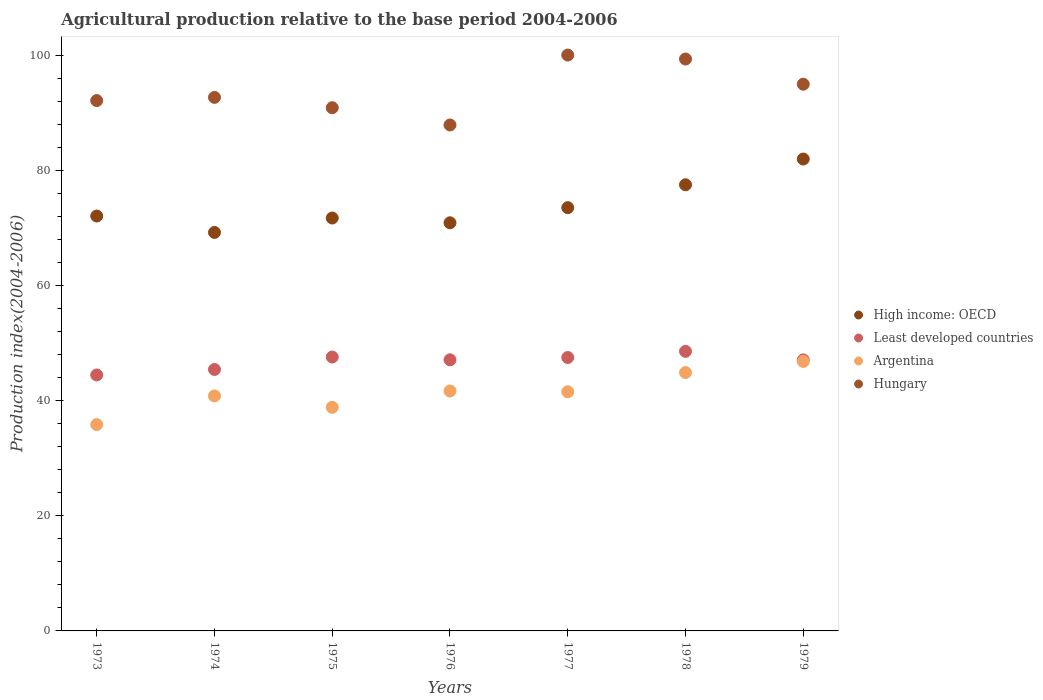Is the number of dotlines equal to the number of legend labels?
Make the answer very short. Yes. What is the agricultural production index in Hungary in 1974?
Make the answer very short. 92.79. Across all years, what is the maximum agricultural production index in Least developed countries?
Your response must be concise. 48.62. Across all years, what is the minimum agricultural production index in High income: OECD?
Your answer should be compact. 69.3. In which year was the agricultural production index in Hungary maximum?
Offer a terse response. 1977. In which year was the agricultural production index in Argentina minimum?
Your response must be concise. 1973. What is the total agricultural production index in Hungary in the graph?
Your answer should be very brief. 658.69. What is the difference between the agricultural production index in Hungary in 1974 and that in 1979?
Provide a succinct answer. -2.29. What is the difference between the agricultural production index in High income: OECD in 1979 and the agricultural production index in Hungary in 1976?
Make the answer very short. -5.92. What is the average agricultural production index in Least developed countries per year?
Offer a very short reply. 46.87. In the year 1979, what is the difference between the agricultural production index in High income: OECD and agricultural production index in Argentina?
Your answer should be very brief. 35.2. What is the ratio of the agricultural production index in Argentina in 1975 to that in 1979?
Offer a terse response. 0.83. Is the agricultural production index in Hungary in 1976 less than that in 1978?
Ensure brevity in your answer.  Yes. What is the difference between the highest and the second highest agricultural production index in Hungary?
Provide a succinct answer. 0.69. What is the difference between the highest and the lowest agricultural production index in Hungary?
Your answer should be very brief. 12.16. Is the sum of the agricultural production index in Least developed countries in 1976 and 1978 greater than the maximum agricultural production index in Hungary across all years?
Offer a very short reply. No. Is it the case that in every year, the sum of the agricultural production index in High income: OECD and agricultural production index in Argentina  is greater than the sum of agricultural production index in Hungary and agricultural production index in Least developed countries?
Your answer should be compact. Yes. How many years are there in the graph?
Offer a very short reply. 7. Are the values on the major ticks of Y-axis written in scientific E-notation?
Keep it short and to the point. No. Where does the legend appear in the graph?
Give a very brief answer. Center right. How are the legend labels stacked?
Your answer should be very brief. Vertical. What is the title of the graph?
Make the answer very short. Agricultural production relative to the base period 2004-2006. Does "East Asia (developing only)" appear as one of the legend labels in the graph?
Offer a terse response. No. What is the label or title of the X-axis?
Give a very brief answer. Years. What is the label or title of the Y-axis?
Provide a succinct answer. Production index(2004-2006). What is the Production index(2004-2006) in High income: OECD in 1973?
Your answer should be compact. 72.15. What is the Production index(2004-2006) in Least developed countries in 1973?
Provide a short and direct response. 44.51. What is the Production index(2004-2006) in Argentina in 1973?
Your answer should be compact. 35.88. What is the Production index(2004-2006) of Hungary in 1973?
Offer a terse response. 92.23. What is the Production index(2004-2006) of High income: OECD in 1974?
Provide a short and direct response. 69.3. What is the Production index(2004-2006) in Least developed countries in 1974?
Make the answer very short. 45.47. What is the Production index(2004-2006) in Argentina in 1974?
Provide a short and direct response. 40.87. What is the Production index(2004-2006) of Hungary in 1974?
Make the answer very short. 92.79. What is the Production index(2004-2006) of High income: OECD in 1975?
Give a very brief answer. 71.81. What is the Production index(2004-2006) in Least developed countries in 1975?
Provide a short and direct response. 47.63. What is the Production index(2004-2006) of Argentina in 1975?
Ensure brevity in your answer.  38.89. What is the Production index(2004-2006) in Hungary in 1975?
Your answer should be very brief. 90.99. What is the Production index(2004-2006) of High income: OECD in 1976?
Ensure brevity in your answer.  70.98. What is the Production index(2004-2006) in Least developed countries in 1976?
Your answer should be very brief. 47.15. What is the Production index(2004-2006) of Argentina in 1976?
Ensure brevity in your answer.  41.73. What is the Production index(2004-2006) in Hungary in 1976?
Give a very brief answer. 87.99. What is the Production index(2004-2006) in High income: OECD in 1977?
Keep it short and to the point. 73.61. What is the Production index(2004-2006) in Least developed countries in 1977?
Give a very brief answer. 47.55. What is the Production index(2004-2006) of Argentina in 1977?
Provide a succinct answer. 41.59. What is the Production index(2004-2006) in Hungary in 1977?
Provide a succinct answer. 100.15. What is the Production index(2004-2006) of High income: OECD in 1978?
Provide a short and direct response. 77.59. What is the Production index(2004-2006) in Least developed countries in 1978?
Your response must be concise. 48.62. What is the Production index(2004-2006) of Argentina in 1978?
Give a very brief answer. 44.93. What is the Production index(2004-2006) in Hungary in 1978?
Give a very brief answer. 99.46. What is the Production index(2004-2006) of High income: OECD in 1979?
Your answer should be compact. 82.07. What is the Production index(2004-2006) in Least developed countries in 1979?
Offer a very short reply. 47.13. What is the Production index(2004-2006) of Argentina in 1979?
Ensure brevity in your answer.  46.87. What is the Production index(2004-2006) of Hungary in 1979?
Make the answer very short. 95.08. Across all years, what is the maximum Production index(2004-2006) of High income: OECD?
Offer a terse response. 82.07. Across all years, what is the maximum Production index(2004-2006) of Least developed countries?
Provide a short and direct response. 48.62. Across all years, what is the maximum Production index(2004-2006) in Argentina?
Offer a terse response. 46.87. Across all years, what is the maximum Production index(2004-2006) in Hungary?
Make the answer very short. 100.15. Across all years, what is the minimum Production index(2004-2006) in High income: OECD?
Provide a succinct answer. 69.3. Across all years, what is the minimum Production index(2004-2006) in Least developed countries?
Make the answer very short. 44.51. Across all years, what is the minimum Production index(2004-2006) in Argentina?
Make the answer very short. 35.88. Across all years, what is the minimum Production index(2004-2006) in Hungary?
Offer a very short reply. 87.99. What is the total Production index(2004-2006) of High income: OECD in the graph?
Offer a terse response. 517.51. What is the total Production index(2004-2006) in Least developed countries in the graph?
Provide a short and direct response. 328.07. What is the total Production index(2004-2006) of Argentina in the graph?
Provide a short and direct response. 290.76. What is the total Production index(2004-2006) of Hungary in the graph?
Make the answer very short. 658.69. What is the difference between the Production index(2004-2006) of High income: OECD in 1973 and that in 1974?
Keep it short and to the point. 2.85. What is the difference between the Production index(2004-2006) of Least developed countries in 1973 and that in 1974?
Keep it short and to the point. -0.96. What is the difference between the Production index(2004-2006) in Argentina in 1973 and that in 1974?
Ensure brevity in your answer.  -4.99. What is the difference between the Production index(2004-2006) in Hungary in 1973 and that in 1974?
Provide a short and direct response. -0.56. What is the difference between the Production index(2004-2006) in High income: OECD in 1973 and that in 1975?
Provide a short and direct response. 0.34. What is the difference between the Production index(2004-2006) in Least developed countries in 1973 and that in 1975?
Make the answer very short. -3.12. What is the difference between the Production index(2004-2006) of Argentina in 1973 and that in 1975?
Keep it short and to the point. -3.01. What is the difference between the Production index(2004-2006) in Hungary in 1973 and that in 1975?
Offer a very short reply. 1.24. What is the difference between the Production index(2004-2006) of High income: OECD in 1973 and that in 1976?
Ensure brevity in your answer.  1.18. What is the difference between the Production index(2004-2006) in Least developed countries in 1973 and that in 1976?
Offer a very short reply. -2.64. What is the difference between the Production index(2004-2006) of Argentina in 1973 and that in 1976?
Your response must be concise. -5.85. What is the difference between the Production index(2004-2006) of Hungary in 1973 and that in 1976?
Provide a succinct answer. 4.24. What is the difference between the Production index(2004-2006) in High income: OECD in 1973 and that in 1977?
Your answer should be compact. -1.46. What is the difference between the Production index(2004-2006) of Least developed countries in 1973 and that in 1977?
Give a very brief answer. -3.04. What is the difference between the Production index(2004-2006) in Argentina in 1973 and that in 1977?
Provide a succinct answer. -5.71. What is the difference between the Production index(2004-2006) of Hungary in 1973 and that in 1977?
Make the answer very short. -7.92. What is the difference between the Production index(2004-2006) of High income: OECD in 1973 and that in 1978?
Give a very brief answer. -5.44. What is the difference between the Production index(2004-2006) of Least developed countries in 1973 and that in 1978?
Provide a short and direct response. -4.11. What is the difference between the Production index(2004-2006) of Argentina in 1973 and that in 1978?
Your answer should be compact. -9.05. What is the difference between the Production index(2004-2006) of Hungary in 1973 and that in 1978?
Your answer should be compact. -7.23. What is the difference between the Production index(2004-2006) of High income: OECD in 1973 and that in 1979?
Provide a succinct answer. -9.91. What is the difference between the Production index(2004-2006) in Least developed countries in 1973 and that in 1979?
Your response must be concise. -2.62. What is the difference between the Production index(2004-2006) in Argentina in 1973 and that in 1979?
Provide a succinct answer. -10.99. What is the difference between the Production index(2004-2006) in Hungary in 1973 and that in 1979?
Give a very brief answer. -2.85. What is the difference between the Production index(2004-2006) of High income: OECD in 1974 and that in 1975?
Provide a short and direct response. -2.51. What is the difference between the Production index(2004-2006) of Least developed countries in 1974 and that in 1975?
Your answer should be very brief. -2.16. What is the difference between the Production index(2004-2006) of Argentina in 1974 and that in 1975?
Your response must be concise. 1.98. What is the difference between the Production index(2004-2006) in High income: OECD in 1974 and that in 1976?
Ensure brevity in your answer.  -1.68. What is the difference between the Production index(2004-2006) in Least developed countries in 1974 and that in 1976?
Ensure brevity in your answer.  -1.68. What is the difference between the Production index(2004-2006) in Argentina in 1974 and that in 1976?
Offer a terse response. -0.86. What is the difference between the Production index(2004-2006) of Hungary in 1974 and that in 1976?
Make the answer very short. 4.8. What is the difference between the Production index(2004-2006) of High income: OECD in 1974 and that in 1977?
Make the answer very short. -4.31. What is the difference between the Production index(2004-2006) of Least developed countries in 1974 and that in 1977?
Your response must be concise. -2.08. What is the difference between the Production index(2004-2006) of Argentina in 1974 and that in 1977?
Give a very brief answer. -0.72. What is the difference between the Production index(2004-2006) of Hungary in 1974 and that in 1977?
Your answer should be compact. -7.36. What is the difference between the Production index(2004-2006) in High income: OECD in 1974 and that in 1978?
Your answer should be compact. -8.29. What is the difference between the Production index(2004-2006) in Least developed countries in 1974 and that in 1978?
Keep it short and to the point. -3.15. What is the difference between the Production index(2004-2006) in Argentina in 1974 and that in 1978?
Make the answer very short. -4.06. What is the difference between the Production index(2004-2006) of Hungary in 1974 and that in 1978?
Offer a very short reply. -6.67. What is the difference between the Production index(2004-2006) in High income: OECD in 1974 and that in 1979?
Your response must be concise. -12.76. What is the difference between the Production index(2004-2006) in Least developed countries in 1974 and that in 1979?
Your answer should be compact. -1.66. What is the difference between the Production index(2004-2006) in Hungary in 1974 and that in 1979?
Provide a succinct answer. -2.29. What is the difference between the Production index(2004-2006) in High income: OECD in 1975 and that in 1976?
Provide a short and direct response. 0.83. What is the difference between the Production index(2004-2006) of Least developed countries in 1975 and that in 1976?
Provide a succinct answer. 0.48. What is the difference between the Production index(2004-2006) in Argentina in 1975 and that in 1976?
Offer a very short reply. -2.84. What is the difference between the Production index(2004-2006) in High income: OECD in 1975 and that in 1977?
Keep it short and to the point. -1.8. What is the difference between the Production index(2004-2006) of Least developed countries in 1975 and that in 1977?
Your answer should be very brief. 0.08. What is the difference between the Production index(2004-2006) of Hungary in 1975 and that in 1977?
Offer a terse response. -9.16. What is the difference between the Production index(2004-2006) in High income: OECD in 1975 and that in 1978?
Offer a very short reply. -5.78. What is the difference between the Production index(2004-2006) of Least developed countries in 1975 and that in 1978?
Make the answer very short. -0.99. What is the difference between the Production index(2004-2006) of Argentina in 1975 and that in 1978?
Provide a succinct answer. -6.04. What is the difference between the Production index(2004-2006) of Hungary in 1975 and that in 1978?
Offer a very short reply. -8.47. What is the difference between the Production index(2004-2006) of High income: OECD in 1975 and that in 1979?
Your response must be concise. -10.26. What is the difference between the Production index(2004-2006) of Least developed countries in 1975 and that in 1979?
Your answer should be compact. 0.5. What is the difference between the Production index(2004-2006) in Argentina in 1975 and that in 1979?
Your answer should be very brief. -7.98. What is the difference between the Production index(2004-2006) in Hungary in 1975 and that in 1979?
Your answer should be very brief. -4.09. What is the difference between the Production index(2004-2006) in High income: OECD in 1976 and that in 1977?
Provide a succinct answer. -2.63. What is the difference between the Production index(2004-2006) of Least developed countries in 1976 and that in 1977?
Your response must be concise. -0.4. What is the difference between the Production index(2004-2006) in Argentina in 1976 and that in 1977?
Your answer should be very brief. 0.14. What is the difference between the Production index(2004-2006) of Hungary in 1976 and that in 1977?
Your answer should be compact. -12.16. What is the difference between the Production index(2004-2006) in High income: OECD in 1976 and that in 1978?
Offer a very short reply. -6.61. What is the difference between the Production index(2004-2006) of Least developed countries in 1976 and that in 1978?
Provide a succinct answer. -1.47. What is the difference between the Production index(2004-2006) in Argentina in 1976 and that in 1978?
Offer a very short reply. -3.2. What is the difference between the Production index(2004-2006) in Hungary in 1976 and that in 1978?
Give a very brief answer. -11.47. What is the difference between the Production index(2004-2006) of High income: OECD in 1976 and that in 1979?
Provide a short and direct response. -11.09. What is the difference between the Production index(2004-2006) of Least developed countries in 1976 and that in 1979?
Your response must be concise. 0.02. What is the difference between the Production index(2004-2006) of Argentina in 1976 and that in 1979?
Offer a terse response. -5.14. What is the difference between the Production index(2004-2006) of Hungary in 1976 and that in 1979?
Make the answer very short. -7.09. What is the difference between the Production index(2004-2006) of High income: OECD in 1977 and that in 1978?
Ensure brevity in your answer.  -3.98. What is the difference between the Production index(2004-2006) in Least developed countries in 1977 and that in 1978?
Your answer should be compact. -1.07. What is the difference between the Production index(2004-2006) in Argentina in 1977 and that in 1978?
Offer a very short reply. -3.34. What is the difference between the Production index(2004-2006) of Hungary in 1977 and that in 1978?
Offer a terse response. 0.69. What is the difference between the Production index(2004-2006) of High income: OECD in 1977 and that in 1979?
Your answer should be very brief. -8.45. What is the difference between the Production index(2004-2006) in Least developed countries in 1977 and that in 1979?
Make the answer very short. 0.42. What is the difference between the Production index(2004-2006) of Argentina in 1977 and that in 1979?
Ensure brevity in your answer.  -5.28. What is the difference between the Production index(2004-2006) in Hungary in 1977 and that in 1979?
Offer a very short reply. 5.07. What is the difference between the Production index(2004-2006) in High income: OECD in 1978 and that in 1979?
Your answer should be compact. -4.48. What is the difference between the Production index(2004-2006) in Least developed countries in 1978 and that in 1979?
Your answer should be compact. 1.49. What is the difference between the Production index(2004-2006) in Argentina in 1978 and that in 1979?
Keep it short and to the point. -1.94. What is the difference between the Production index(2004-2006) of Hungary in 1978 and that in 1979?
Provide a short and direct response. 4.38. What is the difference between the Production index(2004-2006) in High income: OECD in 1973 and the Production index(2004-2006) in Least developed countries in 1974?
Your answer should be very brief. 26.68. What is the difference between the Production index(2004-2006) in High income: OECD in 1973 and the Production index(2004-2006) in Argentina in 1974?
Provide a short and direct response. 31.28. What is the difference between the Production index(2004-2006) in High income: OECD in 1973 and the Production index(2004-2006) in Hungary in 1974?
Provide a succinct answer. -20.64. What is the difference between the Production index(2004-2006) of Least developed countries in 1973 and the Production index(2004-2006) of Argentina in 1974?
Keep it short and to the point. 3.64. What is the difference between the Production index(2004-2006) in Least developed countries in 1973 and the Production index(2004-2006) in Hungary in 1974?
Your response must be concise. -48.28. What is the difference between the Production index(2004-2006) of Argentina in 1973 and the Production index(2004-2006) of Hungary in 1974?
Provide a succinct answer. -56.91. What is the difference between the Production index(2004-2006) in High income: OECD in 1973 and the Production index(2004-2006) in Least developed countries in 1975?
Keep it short and to the point. 24.52. What is the difference between the Production index(2004-2006) of High income: OECD in 1973 and the Production index(2004-2006) of Argentina in 1975?
Give a very brief answer. 33.26. What is the difference between the Production index(2004-2006) of High income: OECD in 1973 and the Production index(2004-2006) of Hungary in 1975?
Your response must be concise. -18.84. What is the difference between the Production index(2004-2006) in Least developed countries in 1973 and the Production index(2004-2006) in Argentina in 1975?
Keep it short and to the point. 5.62. What is the difference between the Production index(2004-2006) in Least developed countries in 1973 and the Production index(2004-2006) in Hungary in 1975?
Ensure brevity in your answer.  -46.48. What is the difference between the Production index(2004-2006) in Argentina in 1973 and the Production index(2004-2006) in Hungary in 1975?
Ensure brevity in your answer.  -55.11. What is the difference between the Production index(2004-2006) in High income: OECD in 1973 and the Production index(2004-2006) in Least developed countries in 1976?
Keep it short and to the point. 25. What is the difference between the Production index(2004-2006) of High income: OECD in 1973 and the Production index(2004-2006) of Argentina in 1976?
Provide a short and direct response. 30.42. What is the difference between the Production index(2004-2006) of High income: OECD in 1973 and the Production index(2004-2006) of Hungary in 1976?
Offer a very short reply. -15.84. What is the difference between the Production index(2004-2006) of Least developed countries in 1973 and the Production index(2004-2006) of Argentina in 1976?
Give a very brief answer. 2.78. What is the difference between the Production index(2004-2006) in Least developed countries in 1973 and the Production index(2004-2006) in Hungary in 1976?
Offer a very short reply. -43.48. What is the difference between the Production index(2004-2006) in Argentina in 1973 and the Production index(2004-2006) in Hungary in 1976?
Your answer should be compact. -52.11. What is the difference between the Production index(2004-2006) of High income: OECD in 1973 and the Production index(2004-2006) of Least developed countries in 1977?
Give a very brief answer. 24.6. What is the difference between the Production index(2004-2006) of High income: OECD in 1973 and the Production index(2004-2006) of Argentina in 1977?
Offer a terse response. 30.56. What is the difference between the Production index(2004-2006) of High income: OECD in 1973 and the Production index(2004-2006) of Hungary in 1977?
Your response must be concise. -28. What is the difference between the Production index(2004-2006) of Least developed countries in 1973 and the Production index(2004-2006) of Argentina in 1977?
Offer a very short reply. 2.92. What is the difference between the Production index(2004-2006) of Least developed countries in 1973 and the Production index(2004-2006) of Hungary in 1977?
Your response must be concise. -55.64. What is the difference between the Production index(2004-2006) in Argentina in 1973 and the Production index(2004-2006) in Hungary in 1977?
Your response must be concise. -64.27. What is the difference between the Production index(2004-2006) in High income: OECD in 1973 and the Production index(2004-2006) in Least developed countries in 1978?
Give a very brief answer. 23.53. What is the difference between the Production index(2004-2006) of High income: OECD in 1973 and the Production index(2004-2006) of Argentina in 1978?
Provide a succinct answer. 27.22. What is the difference between the Production index(2004-2006) in High income: OECD in 1973 and the Production index(2004-2006) in Hungary in 1978?
Ensure brevity in your answer.  -27.31. What is the difference between the Production index(2004-2006) in Least developed countries in 1973 and the Production index(2004-2006) in Argentina in 1978?
Keep it short and to the point. -0.42. What is the difference between the Production index(2004-2006) in Least developed countries in 1973 and the Production index(2004-2006) in Hungary in 1978?
Provide a short and direct response. -54.95. What is the difference between the Production index(2004-2006) of Argentina in 1973 and the Production index(2004-2006) of Hungary in 1978?
Provide a short and direct response. -63.58. What is the difference between the Production index(2004-2006) of High income: OECD in 1973 and the Production index(2004-2006) of Least developed countries in 1979?
Provide a succinct answer. 25.02. What is the difference between the Production index(2004-2006) in High income: OECD in 1973 and the Production index(2004-2006) in Argentina in 1979?
Ensure brevity in your answer.  25.28. What is the difference between the Production index(2004-2006) in High income: OECD in 1973 and the Production index(2004-2006) in Hungary in 1979?
Your answer should be compact. -22.93. What is the difference between the Production index(2004-2006) of Least developed countries in 1973 and the Production index(2004-2006) of Argentina in 1979?
Your answer should be compact. -2.36. What is the difference between the Production index(2004-2006) of Least developed countries in 1973 and the Production index(2004-2006) of Hungary in 1979?
Ensure brevity in your answer.  -50.57. What is the difference between the Production index(2004-2006) of Argentina in 1973 and the Production index(2004-2006) of Hungary in 1979?
Your answer should be very brief. -59.2. What is the difference between the Production index(2004-2006) in High income: OECD in 1974 and the Production index(2004-2006) in Least developed countries in 1975?
Make the answer very short. 21.67. What is the difference between the Production index(2004-2006) in High income: OECD in 1974 and the Production index(2004-2006) in Argentina in 1975?
Provide a succinct answer. 30.41. What is the difference between the Production index(2004-2006) of High income: OECD in 1974 and the Production index(2004-2006) of Hungary in 1975?
Your response must be concise. -21.69. What is the difference between the Production index(2004-2006) of Least developed countries in 1974 and the Production index(2004-2006) of Argentina in 1975?
Provide a short and direct response. 6.58. What is the difference between the Production index(2004-2006) in Least developed countries in 1974 and the Production index(2004-2006) in Hungary in 1975?
Provide a succinct answer. -45.52. What is the difference between the Production index(2004-2006) of Argentina in 1974 and the Production index(2004-2006) of Hungary in 1975?
Offer a very short reply. -50.12. What is the difference between the Production index(2004-2006) in High income: OECD in 1974 and the Production index(2004-2006) in Least developed countries in 1976?
Give a very brief answer. 22.15. What is the difference between the Production index(2004-2006) of High income: OECD in 1974 and the Production index(2004-2006) of Argentina in 1976?
Your response must be concise. 27.57. What is the difference between the Production index(2004-2006) of High income: OECD in 1974 and the Production index(2004-2006) of Hungary in 1976?
Provide a succinct answer. -18.69. What is the difference between the Production index(2004-2006) of Least developed countries in 1974 and the Production index(2004-2006) of Argentina in 1976?
Ensure brevity in your answer.  3.74. What is the difference between the Production index(2004-2006) in Least developed countries in 1974 and the Production index(2004-2006) in Hungary in 1976?
Make the answer very short. -42.52. What is the difference between the Production index(2004-2006) in Argentina in 1974 and the Production index(2004-2006) in Hungary in 1976?
Provide a short and direct response. -47.12. What is the difference between the Production index(2004-2006) of High income: OECD in 1974 and the Production index(2004-2006) of Least developed countries in 1977?
Your answer should be very brief. 21.75. What is the difference between the Production index(2004-2006) in High income: OECD in 1974 and the Production index(2004-2006) in Argentina in 1977?
Keep it short and to the point. 27.71. What is the difference between the Production index(2004-2006) in High income: OECD in 1974 and the Production index(2004-2006) in Hungary in 1977?
Give a very brief answer. -30.85. What is the difference between the Production index(2004-2006) of Least developed countries in 1974 and the Production index(2004-2006) of Argentina in 1977?
Your response must be concise. 3.88. What is the difference between the Production index(2004-2006) of Least developed countries in 1974 and the Production index(2004-2006) of Hungary in 1977?
Provide a short and direct response. -54.68. What is the difference between the Production index(2004-2006) in Argentina in 1974 and the Production index(2004-2006) in Hungary in 1977?
Provide a short and direct response. -59.28. What is the difference between the Production index(2004-2006) of High income: OECD in 1974 and the Production index(2004-2006) of Least developed countries in 1978?
Your answer should be very brief. 20.68. What is the difference between the Production index(2004-2006) in High income: OECD in 1974 and the Production index(2004-2006) in Argentina in 1978?
Keep it short and to the point. 24.37. What is the difference between the Production index(2004-2006) in High income: OECD in 1974 and the Production index(2004-2006) in Hungary in 1978?
Keep it short and to the point. -30.16. What is the difference between the Production index(2004-2006) in Least developed countries in 1974 and the Production index(2004-2006) in Argentina in 1978?
Make the answer very short. 0.54. What is the difference between the Production index(2004-2006) of Least developed countries in 1974 and the Production index(2004-2006) of Hungary in 1978?
Provide a short and direct response. -53.99. What is the difference between the Production index(2004-2006) of Argentina in 1974 and the Production index(2004-2006) of Hungary in 1978?
Keep it short and to the point. -58.59. What is the difference between the Production index(2004-2006) of High income: OECD in 1974 and the Production index(2004-2006) of Least developed countries in 1979?
Offer a terse response. 22.17. What is the difference between the Production index(2004-2006) in High income: OECD in 1974 and the Production index(2004-2006) in Argentina in 1979?
Your answer should be very brief. 22.43. What is the difference between the Production index(2004-2006) of High income: OECD in 1974 and the Production index(2004-2006) of Hungary in 1979?
Provide a succinct answer. -25.78. What is the difference between the Production index(2004-2006) in Least developed countries in 1974 and the Production index(2004-2006) in Argentina in 1979?
Offer a very short reply. -1.4. What is the difference between the Production index(2004-2006) of Least developed countries in 1974 and the Production index(2004-2006) of Hungary in 1979?
Offer a terse response. -49.61. What is the difference between the Production index(2004-2006) of Argentina in 1974 and the Production index(2004-2006) of Hungary in 1979?
Give a very brief answer. -54.21. What is the difference between the Production index(2004-2006) of High income: OECD in 1975 and the Production index(2004-2006) of Least developed countries in 1976?
Provide a short and direct response. 24.66. What is the difference between the Production index(2004-2006) in High income: OECD in 1975 and the Production index(2004-2006) in Argentina in 1976?
Ensure brevity in your answer.  30.08. What is the difference between the Production index(2004-2006) of High income: OECD in 1975 and the Production index(2004-2006) of Hungary in 1976?
Offer a very short reply. -16.18. What is the difference between the Production index(2004-2006) in Least developed countries in 1975 and the Production index(2004-2006) in Argentina in 1976?
Give a very brief answer. 5.9. What is the difference between the Production index(2004-2006) of Least developed countries in 1975 and the Production index(2004-2006) of Hungary in 1976?
Make the answer very short. -40.36. What is the difference between the Production index(2004-2006) of Argentina in 1975 and the Production index(2004-2006) of Hungary in 1976?
Make the answer very short. -49.1. What is the difference between the Production index(2004-2006) of High income: OECD in 1975 and the Production index(2004-2006) of Least developed countries in 1977?
Give a very brief answer. 24.26. What is the difference between the Production index(2004-2006) of High income: OECD in 1975 and the Production index(2004-2006) of Argentina in 1977?
Your response must be concise. 30.22. What is the difference between the Production index(2004-2006) of High income: OECD in 1975 and the Production index(2004-2006) of Hungary in 1977?
Make the answer very short. -28.34. What is the difference between the Production index(2004-2006) in Least developed countries in 1975 and the Production index(2004-2006) in Argentina in 1977?
Make the answer very short. 6.04. What is the difference between the Production index(2004-2006) of Least developed countries in 1975 and the Production index(2004-2006) of Hungary in 1977?
Your answer should be very brief. -52.52. What is the difference between the Production index(2004-2006) in Argentina in 1975 and the Production index(2004-2006) in Hungary in 1977?
Your answer should be compact. -61.26. What is the difference between the Production index(2004-2006) in High income: OECD in 1975 and the Production index(2004-2006) in Least developed countries in 1978?
Keep it short and to the point. 23.19. What is the difference between the Production index(2004-2006) in High income: OECD in 1975 and the Production index(2004-2006) in Argentina in 1978?
Your answer should be compact. 26.88. What is the difference between the Production index(2004-2006) in High income: OECD in 1975 and the Production index(2004-2006) in Hungary in 1978?
Your answer should be compact. -27.65. What is the difference between the Production index(2004-2006) in Least developed countries in 1975 and the Production index(2004-2006) in Argentina in 1978?
Keep it short and to the point. 2.7. What is the difference between the Production index(2004-2006) in Least developed countries in 1975 and the Production index(2004-2006) in Hungary in 1978?
Your answer should be very brief. -51.83. What is the difference between the Production index(2004-2006) in Argentina in 1975 and the Production index(2004-2006) in Hungary in 1978?
Provide a short and direct response. -60.57. What is the difference between the Production index(2004-2006) of High income: OECD in 1975 and the Production index(2004-2006) of Least developed countries in 1979?
Provide a short and direct response. 24.67. What is the difference between the Production index(2004-2006) in High income: OECD in 1975 and the Production index(2004-2006) in Argentina in 1979?
Your answer should be compact. 24.94. What is the difference between the Production index(2004-2006) in High income: OECD in 1975 and the Production index(2004-2006) in Hungary in 1979?
Ensure brevity in your answer.  -23.27. What is the difference between the Production index(2004-2006) of Least developed countries in 1975 and the Production index(2004-2006) of Argentina in 1979?
Your response must be concise. 0.76. What is the difference between the Production index(2004-2006) in Least developed countries in 1975 and the Production index(2004-2006) in Hungary in 1979?
Offer a terse response. -47.45. What is the difference between the Production index(2004-2006) of Argentina in 1975 and the Production index(2004-2006) of Hungary in 1979?
Provide a short and direct response. -56.19. What is the difference between the Production index(2004-2006) of High income: OECD in 1976 and the Production index(2004-2006) of Least developed countries in 1977?
Ensure brevity in your answer.  23.43. What is the difference between the Production index(2004-2006) of High income: OECD in 1976 and the Production index(2004-2006) of Argentina in 1977?
Provide a succinct answer. 29.39. What is the difference between the Production index(2004-2006) of High income: OECD in 1976 and the Production index(2004-2006) of Hungary in 1977?
Provide a short and direct response. -29.17. What is the difference between the Production index(2004-2006) in Least developed countries in 1976 and the Production index(2004-2006) in Argentina in 1977?
Your answer should be very brief. 5.56. What is the difference between the Production index(2004-2006) of Least developed countries in 1976 and the Production index(2004-2006) of Hungary in 1977?
Your answer should be compact. -53. What is the difference between the Production index(2004-2006) of Argentina in 1976 and the Production index(2004-2006) of Hungary in 1977?
Provide a short and direct response. -58.42. What is the difference between the Production index(2004-2006) of High income: OECD in 1976 and the Production index(2004-2006) of Least developed countries in 1978?
Your answer should be compact. 22.36. What is the difference between the Production index(2004-2006) of High income: OECD in 1976 and the Production index(2004-2006) of Argentina in 1978?
Offer a very short reply. 26.05. What is the difference between the Production index(2004-2006) of High income: OECD in 1976 and the Production index(2004-2006) of Hungary in 1978?
Your answer should be very brief. -28.48. What is the difference between the Production index(2004-2006) of Least developed countries in 1976 and the Production index(2004-2006) of Argentina in 1978?
Ensure brevity in your answer.  2.22. What is the difference between the Production index(2004-2006) in Least developed countries in 1976 and the Production index(2004-2006) in Hungary in 1978?
Keep it short and to the point. -52.31. What is the difference between the Production index(2004-2006) of Argentina in 1976 and the Production index(2004-2006) of Hungary in 1978?
Provide a short and direct response. -57.73. What is the difference between the Production index(2004-2006) in High income: OECD in 1976 and the Production index(2004-2006) in Least developed countries in 1979?
Your answer should be compact. 23.84. What is the difference between the Production index(2004-2006) in High income: OECD in 1976 and the Production index(2004-2006) in Argentina in 1979?
Offer a terse response. 24.11. What is the difference between the Production index(2004-2006) of High income: OECD in 1976 and the Production index(2004-2006) of Hungary in 1979?
Provide a succinct answer. -24.1. What is the difference between the Production index(2004-2006) in Least developed countries in 1976 and the Production index(2004-2006) in Argentina in 1979?
Your answer should be very brief. 0.28. What is the difference between the Production index(2004-2006) in Least developed countries in 1976 and the Production index(2004-2006) in Hungary in 1979?
Your answer should be compact. -47.93. What is the difference between the Production index(2004-2006) of Argentina in 1976 and the Production index(2004-2006) of Hungary in 1979?
Provide a succinct answer. -53.35. What is the difference between the Production index(2004-2006) of High income: OECD in 1977 and the Production index(2004-2006) of Least developed countries in 1978?
Keep it short and to the point. 24.99. What is the difference between the Production index(2004-2006) of High income: OECD in 1977 and the Production index(2004-2006) of Argentina in 1978?
Keep it short and to the point. 28.68. What is the difference between the Production index(2004-2006) of High income: OECD in 1977 and the Production index(2004-2006) of Hungary in 1978?
Offer a terse response. -25.85. What is the difference between the Production index(2004-2006) in Least developed countries in 1977 and the Production index(2004-2006) in Argentina in 1978?
Your answer should be very brief. 2.62. What is the difference between the Production index(2004-2006) of Least developed countries in 1977 and the Production index(2004-2006) of Hungary in 1978?
Offer a very short reply. -51.91. What is the difference between the Production index(2004-2006) in Argentina in 1977 and the Production index(2004-2006) in Hungary in 1978?
Give a very brief answer. -57.87. What is the difference between the Production index(2004-2006) in High income: OECD in 1977 and the Production index(2004-2006) in Least developed countries in 1979?
Give a very brief answer. 26.48. What is the difference between the Production index(2004-2006) of High income: OECD in 1977 and the Production index(2004-2006) of Argentina in 1979?
Keep it short and to the point. 26.74. What is the difference between the Production index(2004-2006) of High income: OECD in 1977 and the Production index(2004-2006) of Hungary in 1979?
Keep it short and to the point. -21.47. What is the difference between the Production index(2004-2006) in Least developed countries in 1977 and the Production index(2004-2006) in Argentina in 1979?
Your answer should be very brief. 0.68. What is the difference between the Production index(2004-2006) in Least developed countries in 1977 and the Production index(2004-2006) in Hungary in 1979?
Make the answer very short. -47.53. What is the difference between the Production index(2004-2006) in Argentina in 1977 and the Production index(2004-2006) in Hungary in 1979?
Keep it short and to the point. -53.49. What is the difference between the Production index(2004-2006) of High income: OECD in 1978 and the Production index(2004-2006) of Least developed countries in 1979?
Keep it short and to the point. 30.46. What is the difference between the Production index(2004-2006) in High income: OECD in 1978 and the Production index(2004-2006) in Argentina in 1979?
Give a very brief answer. 30.72. What is the difference between the Production index(2004-2006) of High income: OECD in 1978 and the Production index(2004-2006) of Hungary in 1979?
Offer a very short reply. -17.49. What is the difference between the Production index(2004-2006) in Least developed countries in 1978 and the Production index(2004-2006) in Argentina in 1979?
Your answer should be very brief. 1.75. What is the difference between the Production index(2004-2006) of Least developed countries in 1978 and the Production index(2004-2006) of Hungary in 1979?
Make the answer very short. -46.46. What is the difference between the Production index(2004-2006) of Argentina in 1978 and the Production index(2004-2006) of Hungary in 1979?
Ensure brevity in your answer.  -50.15. What is the average Production index(2004-2006) in High income: OECD per year?
Make the answer very short. 73.93. What is the average Production index(2004-2006) of Least developed countries per year?
Make the answer very short. 46.87. What is the average Production index(2004-2006) in Argentina per year?
Provide a succinct answer. 41.54. What is the average Production index(2004-2006) in Hungary per year?
Ensure brevity in your answer.  94.1. In the year 1973, what is the difference between the Production index(2004-2006) in High income: OECD and Production index(2004-2006) in Least developed countries?
Your response must be concise. 27.64. In the year 1973, what is the difference between the Production index(2004-2006) of High income: OECD and Production index(2004-2006) of Argentina?
Offer a terse response. 36.27. In the year 1973, what is the difference between the Production index(2004-2006) in High income: OECD and Production index(2004-2006) in Hungary?
Your answer should be compact. -20.08. In the year 1973, what is the difference between the Production index(2004-2006) in Least developed countries and Production index(2004-2006) in Argentina?
Provide a succinct answer. 8.63. In the year 1973, what is the difference between the Production index(2004-2006) of Least developed countries and Production index(2004-2006) of Hungary?
Offer a very short reply. -47.72. In the year 1973, what is the difference between the Production index(2004-2006) of Argentina and Production index(2004-2006) of Hungary?
Keep it short and to the point. -56.35. In the year 1974, what is the difference between the Production index(2004-2006) of High income: OECD and Production index(2004-2006) of Least developed countries?
Your answer should be compact. 23.83. In the year 1974, what is the difference between the Production index(2004-2006) of High income: OECD and Production index(2004-2006) of Argentina?
Ensure brevity in your answer.  28.43. In the year 1974, what is the difference between the Production index(2004-2006) in High income: OECD and Production index(2004-2006) in Hungary?
Offer a terse response. -23.49. In the year 1974, what is the difference between the Production index(2004-2006) in Least developed countries and Production index(2004-2006) in Argentina?
Your response must be concise. 4.6. In the year 1974, what is the difference between the Production index(2004-2006) in Least developed countries and Production index(2004-2006) in Hungary?
Give a very brief answer. -47.32. In the year 1974, what is the difference between the Production index(2004-2006) in Argentina and Production index(2004-2006) in Hungary?
Ensure brevity in your answer.  -51.92. In the year 1975, what is the difference between the Production index(2004-2006) of High income: OECD and Production index(2004-2006) of Least developed countries?
Keep it short and to the point. 24.18. In the year 1975, what is the difference between the Production index(2004-2006) in High income: OECD and Production index(2004-2006) in Argentina?
Keep it short and to the point. 32.92. In the year 1975, what is the difference between the Production index(2004-2006) in High income: OECD and Production index(2004-2006) in Hungary?
Make the answer very short. -19.18. In the year 1975, what is the difference between the Production index(2004-2006) of Least developed countries and Production index(2004-2006) of Argentina?
Offer a very short reply. 8.74. In the year 1975, what is the difference between the Production index(2004-2006) in Least developed countries and Production index(2004-2006) in Hungary?
Your response must be concise. -43.36. In the year 1975, what is the difference between the Production index(2004-2006) of Argentina and Production index(2004-2006) of Hungary?
Offer a terse response. -52.1. In the year 1976, what is the difference between the Production index(2004-2006) of High income: OECD and Production index(2004-2006) of Least developed countries?
Ensure brevity in your answer.  23.83. In the year 1976, what is the difference between the Production index(2004-2006) in High income: OECD and Production index(2004-2006) in Argentina?
Provide a short and direct response. 29.25. In the year 1976, what is the difference between the Production index(2004-2006) in High income: OECD and Production index(2004-2006) in Hungary?
Make the answer very short. -17.01. In the year 1976, what is the difference between the Production index(2004-2006) of Least developed countries and Production index(2004-2006) of Argentina?
Your answer should be very brief. 5.42. In the year 1976, what is the difference between the Production index(2004-2006) in Least developed countries and Production index(2004-2006) in Hungary?
Provide a short and direct response. -40.84. In the year 1976, what is the difference between the Production index(2004-2006) in Argentina and Production index(2004-2006) in Hungary?
Your answer should be very brief. -46.26. In the year 1977, what is the difference between the Production index(2004-2006) of High income: OECD and Production index(2004-2006) of Least developed countries?
Ensure brevity in your answer.  26.06. In the year 1977, what is the difference between the Production index(2004-2006) in High income: OECD and Production index(2004-2006) in Argentina?
Make the answer very short. 32.02. In the year 1977, what is the difference between the Production index(2004-2006) of High income: OECD and Production index(2004-2006) of Hungary?
Give a very brief answer. -26.54. In the year 1977, what is the difference between the Production index(2004-2006) in Least developed countries and Production index(2004-2006) in Argentina?
Give a very brief answer. 5.96. In the year 1977, what is the difference between the Production index(2004-2006) in Least developed countries and Production index(2004-2006) in Hungary?
Provide a succinct answer. -52.6. In the year 1977, what is the difference between the Production index(2004-2006) in Argentina and Production index(2004-2006) in Hungary?
Offer a very short reply. -58.56. In the year 1978, what is the difference between the Production index(2004-2006) in High income: OECD and Production index(2004-2006) in Least developed countries?
Your response must be concise. 28.97. In the year 1978, what is the difference between the Production index(2004-2006) in High income: OECD and Production index(2004-2006) in Argentina?
Your response must be concise. 32.66. In the year 1978, what is the difference between the Production index(2004-2006) in High income: OECD and Production index(2004-2006) in Hungary?
Offer a very short reply. -21.87. In the year 1978, what is the difference between the Production index(2004-2006) in Least developed countries and Production index(2004-2006) in Argentina?
Keep it short and to the point. 3.69. In the year 1978, what is the difference between the Production index(2004-2006) in Least developed countries and Production index(2004-2006) in Hungary?
Provide a succinct answer. -50.84. In the year 1978, what is the difference between the Production index(2004-2006) of Argentina and Production index(2004-2006) of Hungary?
Provide a short and direct response. -54.53. In the year 1979, what is the difference between the Production index(2004-2006) of High income: OECD and Production index(2004-2006) of Least developed countries?
Ensure brevity in your answer.  34.93. In the year 1979, what is the difference between the Production index(2004-2006) of High income: OECD and Production index(2004-2006) of Argentina?
Offer a terse response. 35.2. In the year 1979, what is the difference between the Production index(2004-2006) of High income: OECD and Production index(2004-2006) of Hungary?
Offer a terse response. -13.01. In the year 1979, what is the difference between the Production index(2004-2006) of Least developed countries and Production index(2004-2006) of Argentina?
Offer a terse response. 0.26. In the year 1979, what is the difference between the Production index(2004-2006) in Least developed countries and Production index(2004-2006) in Hungary?
Provide a succinct answer. -47.95. In the year 1979, what is the difference between the Production index(2004-2006) in Argentina and Production index(2004-2006) in Hungary?
Give a very brief answer. -48.21. What is the ratio of the Production index(2004-2006) of High income: OECD in 1973 to that in 1974?
Your response must be concise. 1.04. What is the ratio of the Production index(2004-2006) of Least developed countries in 1973 to that in 1974?
Your answer should be very brief. 0.98. What is the ratio of the Production index(2004-2006) in Argentina in 1973 to that in 1974?
Offer a terse response. 0.88. What is the ratio of the Production index(2004-2006) of Hungary in 1973 to that in 1974?
Give a very brief answer. 0.99. What is the ratio of the Production index(2004-2006) in Least developed countries in 1973 to that in 1975?
Your answer should be compact. 0.93. What is the ratio of the Production index(2004-2006) of Argentina in 1973 to that in 1975?
Keep it short and to the point. 0.92. What is the ratio of the Production index(2004-2006) in Hungary in 1973 to that in 1975?
Ensure brevity in your answer.  1.01. What is the ratio of the Production index(2004-2006) of High income: OECD in 1973 to that in 1976?
Give a very brief answer. 1.02. What is the ratio of the Production index(2004-2006) in Least developed countries in 1973 to that in 1976?
Your response must be concise. 0.94. What is the ratio of the Production index(2004-2006) in Argentina in 1973 to that in 1976?
Your answer should be compact. 0.86. What is the ratio of the Production index(2004-2006) of Hungary in 1973 to that in 1976?
Ensure brevity in your answer.  1.05. What is the ratio of the Production index(2004-2006) of High income: OECD in 1973 to that in 1977?
Provide a succinct answer. 0.98. What is the ratio of the Production index(2004-2006) in Least developed countries in 1973 to that in 1977?
Your answer should be very brief. 0.94. What is the ratio of the Production index(2004-2006) of Argentina in 1973 to that in 1977?
Your answer should be compact. 0.86. What is the ratio of the Production index(2004-2006) of Hungary in 1973 to that in 1977?
Your response must be concise. 0.92. What is the ratio of the Production index(2004-2006) in High income: OECD in 1973 to that in 1978?
Your response must be concise. 0.93. What is the ratio of the Production index(2004-2006) in Least developed countries in 1973 to that in 1978?
Ensure brevity in your answer.  0.92. What is the ratio of the Production index(2004-2006) of Argentina in 1973 to that in 1978?
Your answer should be compact. 0.8. What is the ratio of the Production index(2004-2006) of Hungary in 1973 to that in 1978?
Your answer should be compact. 0.93. What is the ratio of the Production index(2004-2006) in High income: OECD in 1973 to that in 1979?
Ensure brevity in your answer.  0.88. What is the ratio of the Production index(2004-2006) of Argentina in 1973 to that in 1979?
Ensure brevity in your answer.  0.77. What is the ratio of the Production index(2004-2006) in Hungary in 1973 to that in 1979?
Make the answer very short. 0.97. What is the ratio of the Production index(2004-2006) in High income: OECD in 1974 to that in 1975?
Give a very brief answer. 0.97. What is the ratio of the Production index(2004-2006) of Least developed countries in 1974 to that in 1975?
Keep it short and to the point. 0.95. What is the ratio of the Production index(2004-2006) of Argentina in 1974 to that in 1975?
Keep it short and to the point. 1.05. What is the ratio of the Production index(2004-2006) in Hungary in 1974 to that in 1975?
Provide a short and direct response. 1.02. What is the ratio of the Production index(2004-2006) in High income: OECD in 1974 to that in 1976?
Keep it short and to the point. 0.98. What is the ratio of the Production index(2004-2006) of Least developed countries in 1974 to that in 1976?
Your answer should be compact. 0.96. What is the ratio of the Production index(2004-2006) of Argentina in 1974 to that in 1976?
Your answer should be very brief. 0.98. What is the ratio of the Production index(2004-2006) in Hungary in 1974 to that in 1976?
Ensure brevity in your answer.  1.05. What is the ratio of the Production index(2004-2006) in High income: OECD in 1974 to that in 1977?
Provide a succinct answer. 0.94. What is the ratio of the Production index(2004-2006) in Least developed countries in 1974 to that in 1977?
Provide a succinct answer. 0.96. What is the ratio of the Production index(2004-2006) in Argentina in 1974 to that in 1977?
Provide a short and direct response. 0.98. What is the ratio of the Production index(2004-2006) of Hungary in 1974 to that in 1977?
Your answer should be compact. 0.93. What is the ratio of the Production index(2004-2006) in High income: OECD in 1974 to that in 1978?
Give a very brief answer. 0.89. What is the ratio of the Production index(2004-2006) in Least developed countries in 1974 to that in 1978?
Offer a very short reply. 0.94. What is the ratio of the Production index(2004-2006) in Argentina in 1974 to that in 1978?
Ensure brevity in your answer.  0.91. What is the ratio of the Production index(2004-2006) in Hungary in 1974 to that in 1978?
Your answer should be compact. 0.93. What is the ratio of the Production index(2004-2006) in High income: OECD in 1974 to that in 1979?
Your answer should be very brief. 0.84. What is the ratio of the Production index(2004-2006) of Least developed countries in 1974 to that in 1979?
Provide a short and direct response. 0.96. What is the ratio of the Production index(2004-2006) in Argentina in 1974 to that in 1979?
Offer a terse response. 0.87. What is the ratio of the Production index(2004-2006) in Hungary in 1974 to that in 1979?
Provide a succinct answer. 0.98. What is the ratio of the Production index(2004-2006) in High income: OECD in 1975 to that in 1976?
Your response must be concise. 1.01. What is the ratio of the Production index(2004-2006) of Least developed countries in 1975 to that in 1976?
Your answer should be very brief. 1.01. What is the ratio of the Production index(2004-2006) of Argentina in 1975 to that in 1976?
Ensure brevity in your answer.  0.93. What is the ratio of the Production index(2004-2006) in Hungary in 1975 to that in 1976?
Make the answer very short. 1.03. What is the ratio of the Production index(2004-2006) of High income: OECD in 1975 to that in 1977?
Provide a succinct answer. 0.98. What is the ratio of the Production index(2004-2006) in Least developed countries in 1975 to that in 1977?
Your response must be concise. 1. What is the ratio of the Production index(2004-2006) of Argentina in 1975 to that in 1977?
Provide a succinct answer. 0.94. What is the ratio of the Production index(2004-2006) in Hungary in 1975 to that in 1977?
Provide a succinct answer. 0.91. What is the ratio of the Production index(2004-2006) in High income: OECD in 1975 to that in 1978?
Provide a short and direct response. 0.93. What is the ratio of the Production index(2004-2006) of Least developed countries in 1975 to that in 1978?
Provide a short and direct response. 0.98. What is the ratio of the Production index(2004-2006) of Argentina in 1975 to that in 1978?
Provide a succinct answer. 0.87. What is the ratio of the Production index(2004-2006) of Hungary in 1975 to that in 1978?
Your answer should be compact. 0.91. What is the ratio of the Production index(2004-2006) of High income: OECD in 1975 to that in 1979?
Keep it short and to the point. 0.88. What is the ratio of the Production index(2004-2006) in Least developed countries in 1975 to that in 1979?
Offer a terse response. 1.01. What is the ratio of the Production index(2004-2006) in Argentina in 1975 to that in 1979?
Your answer should be very brief. 0.83. What is the ratio of the Production index(2004-2006) in Hungary in 1975 to that in 1979?
Your answer should be compact. 0.96. What is the ratio of the Production index(2004-2006) in High income: OECD in 1976 to that in 1977?
Make the answer very short. 0.96. What is the ratio of the Production index(2004-2006) of Hungary in 1976 to that in 1977?
Ensure brevity in your answer.  0.88. What is the ratio of the Production index(2004-2006) in High income: OECD in 1976 to that in 1978?
Your answer should be compact. 0.91. What is the ratio of the Production index(2004-2006) in Least developed countries in 1976 to that in 1978?
Your answer should be compact. 0.97. What is the ratio of the Production index(2004-2006) of Argentina in 1976 to that in 1978?
Provide a short and direct response. 0.93. What is the ratio of the Production index(2004-2006) in Hungary in 1976 to that in 1978?
Ensure brevity in your answer.  0.88. What is the ratio of the Production index(2004-2006) in High income: OECD in 1976 to that in 1979?
Keep it short and to the point. 0.86. What is the ratio of the Production index(2004-2006) in Argentina in 1976 to that in 1979?
Your answer should be very brief. 0.89. What is the ratio of the Production index(2004-2006) of Hungary in 1976 to that in 1979?
Your response must be concise. 0.93. What is the ratio of the Production index(2004-2006) in High income: OECD in 1977 to that in 1978?
Give a very brief answer. 0.95. What is the ratio of the Production index(2004-2006) in Argentina in 1977 to that in 1978?
Provide a short and direct response. 0.93. What is the ratio of the Production index(2004-2006) in High income: OECD in 1977 to that in 1979?
Your answer should be very brief. 0.9. What is the ratio of the Production index(2004-2006) of Least developed countries in 1977 to that in 1979?
Make the answer very short. 1.01. What is the ratio of the Production index(2004-2006) of Argentina in 1977 to that in 1979?
Ensure brevity in your answer.  0.89. What is the ratio of the Production index(2004-2006) in Hungary in 1977 to that in 1979?
Provide a short and direct response. 1.05. What is the ratio of the Production index(2004-2006) in High income: OECD in 1978 to that in 1979?
Your answer should be very brief. 0.95. What is the ratio of the Production index(2004-2006) of Least developed countries in 1978 to that in 1979?
Your answer should be compact. 1.03. What is the ratio of the Production index(2004-2006) of Argentina in 1978 to that in 1979?
Give a very brief answer. 0.96. What is the ratio of the Production index(2004-2006) in Hungary in 1978 to that in 1979?
Provide a succinct answer. 1.05. What is the difference between the highest and the second highest Production index(2004-2006) of High income: OECD?
Your response must be concise. 4.48. What is the difference between the highest and the second highest Production index(2004-2006) in Least developed countries?
Offer a terse response. 0.99. What is the difference between the highest and the second highest Production index(2004-2006) in Argentina?
Provide a succinct answer. 1.94. What is the difference between the highest and the second highest Production index(2004-2006) in Hungary?
Offer a terse response. 0.69. What is the difference between the highest and the lowest Production index(2004-2006) in High income: OECD?
Provide a short and direct response. 12.76. What is the difference between the highest and the lowest Production index(2004-2006) of Least developed countries?
Offer a terse response. 4.11. What is the difference between the highest and the lowest Production index(2004-2006) in Argentina?
Your response must be concise. 10.99. What is the difference between the highest and the lowest Production index(2004-2006) of Hungary?
Your answer should be very brief. 12.16. 